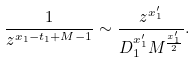<formula> <loc_0><loc_0><loc_500><loc_500>\frac { 1 } { z ^ { x _ { 1 } - t _ { 1 } + M - 1 } } \sim \frac { z ^ { x ^ { \prime } _ { 1 } } } { D _ { 1 } ^ { x ^ { \prime } _ { 1 } } M ^ { \frac { x ^ { \prime } _ { 1 } } { 2 } } } .</formula> 